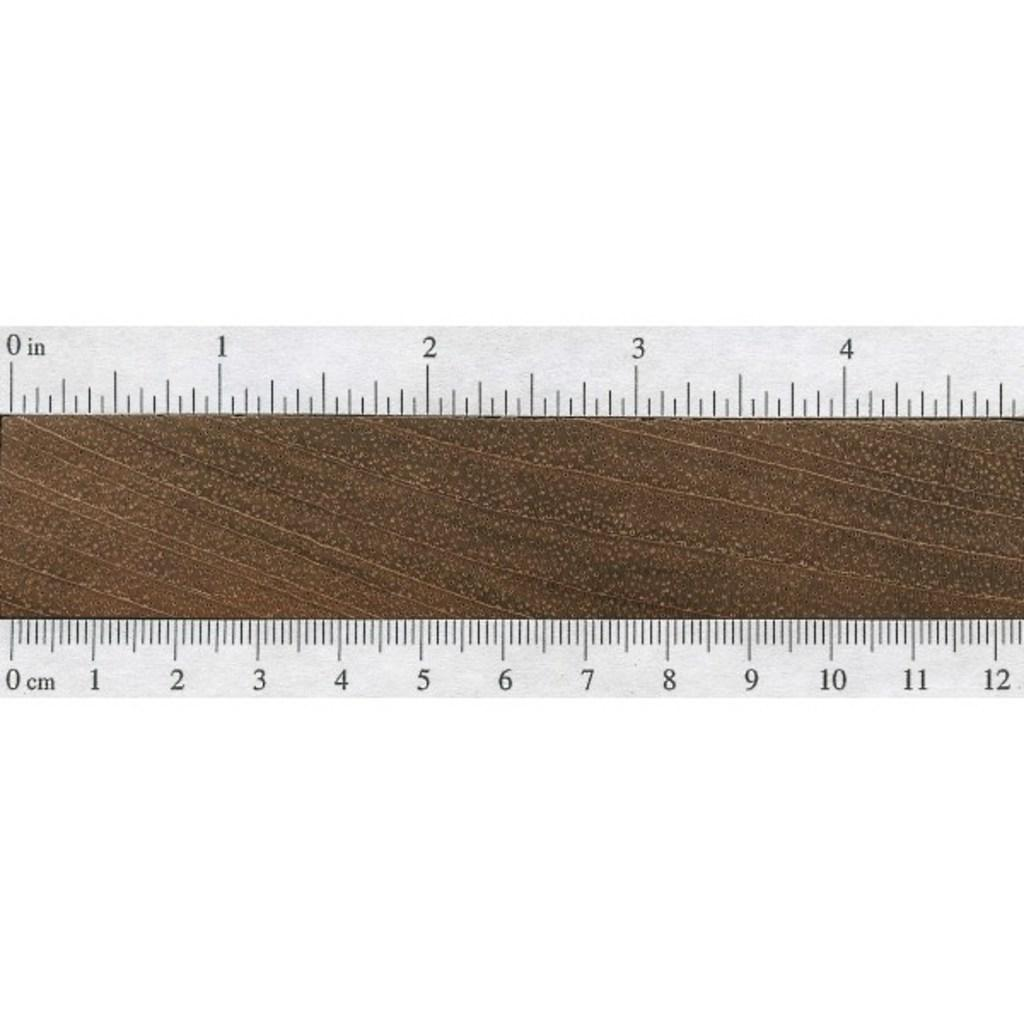<image>
Write a terse but informative summary of the picture. A ruler with inches on the top and centimetres on the bottom 